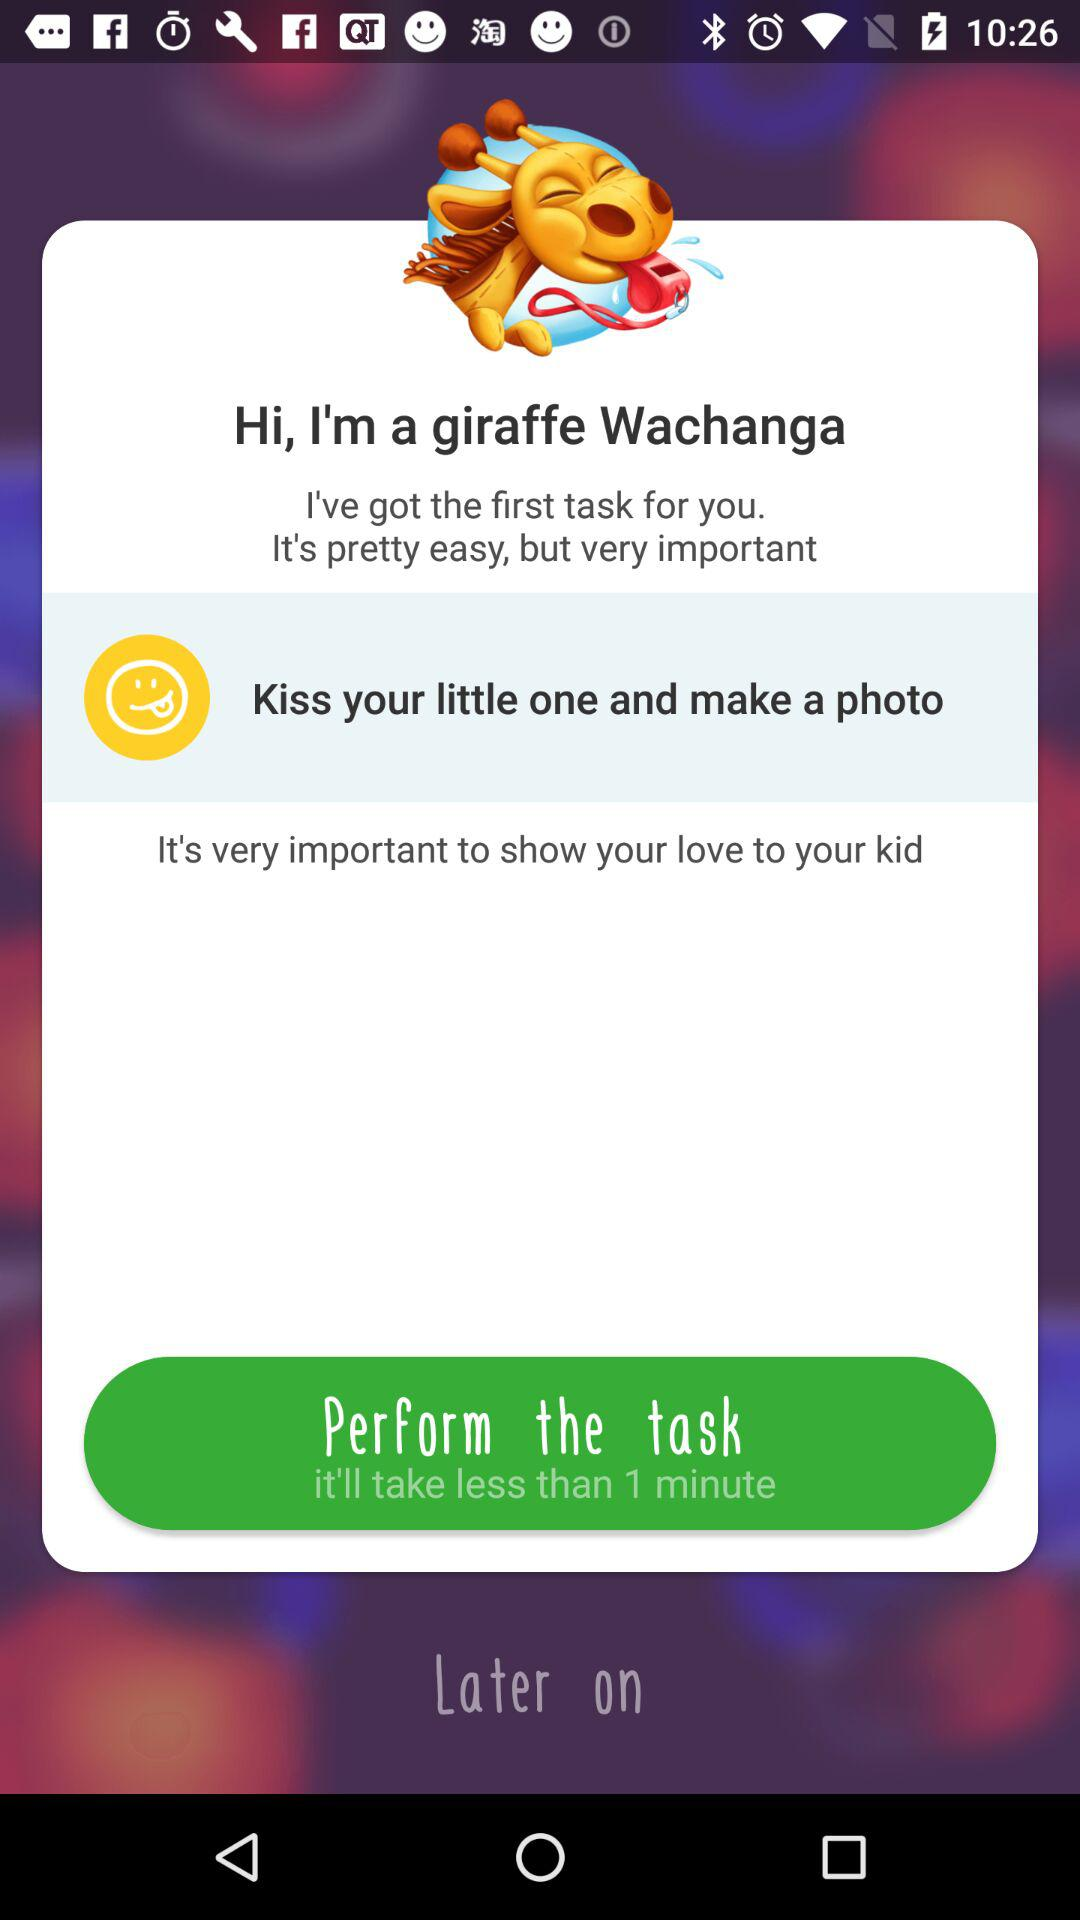How long will it take to perform the task? It will take less than 1 minute. 